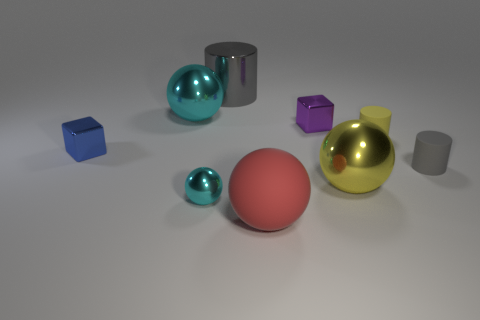How many other objects are there of the same size as the yellow matte object?
Keep it short and to the point. 4. What is the shape of the cyan thing that is in front of the metallic block that is on the left side of the large gray cylinder?
Provide a succinct answer. Sphere. There is a large metal sphere left of the big red rubber sphere; is its color the same as the tiny ball?
Ensure brevity in your answer.  Yes. There is a rubber thing that is in front of the tiny blue shiny thing and behind the large red object; what color is it?
Offer a terse response. Gray. Are there any blue objects made of the same material as the purple cube?
Provide a short and direct response. Yes. What is the size of the red sphere?
Your answer should be compact. Large. There is a rubber cylinder left of the tiny rubber cylinder that is in front of the tiny yellow matte cylinder; what is its size?
Offer a terse response. Small. There is a purple thing that is the same shape as the tiny blue metal object; what material is it?
Your response must be concise. Metal. What number of tiny balls are there?
Make the answer very short. 1. The object that is right of the small cylinder behind the gray cylinder that is on the right side of the large gray cylinder is what color?
Give a very brief answer. Gray. 